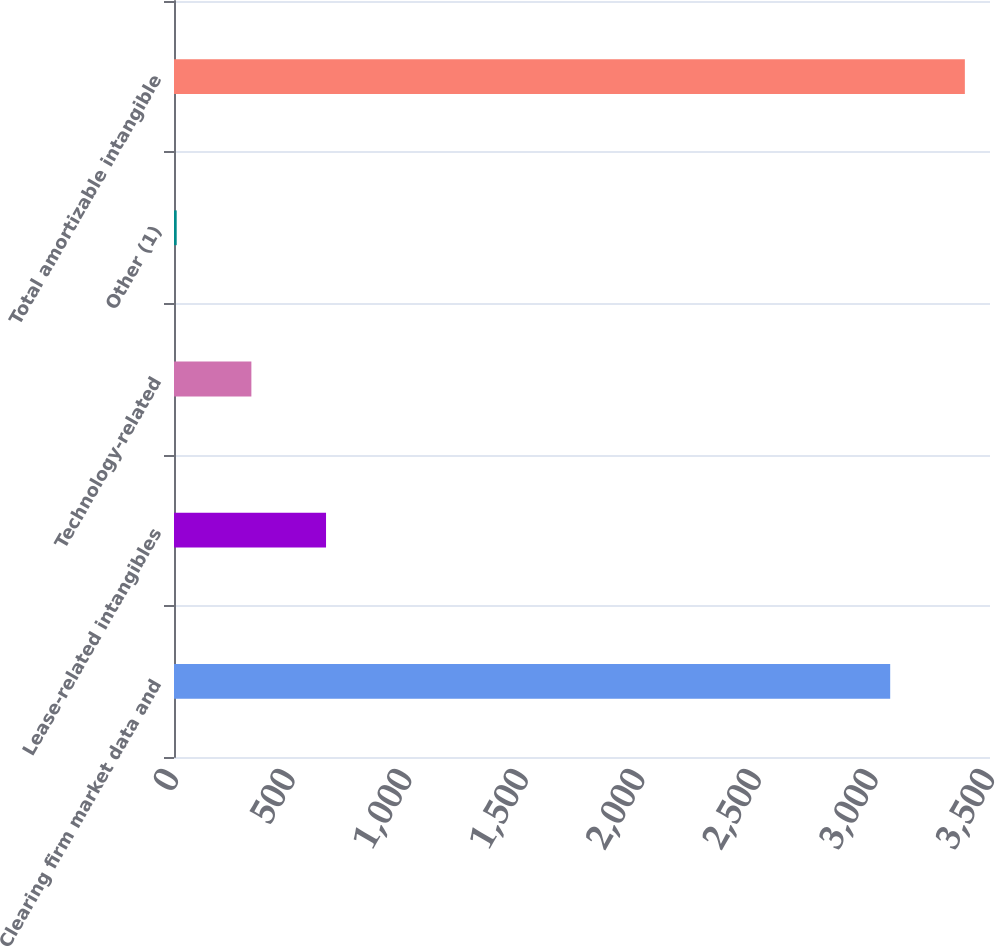Convert chart to OTSL. <chart><loc_0><loc_0><loc_500><loc_500><bar_chart><fcel>Clearing firm market data and<fcel>Lease-related intangibles<fcel>Technology-related<fcel>Other (1)<fcel>Total amortizable intangible<nl><fcel>3071.9<fcel>652.1<fcel>331.85<fcel>11.6<fcel>3392.15<nl></chart> 